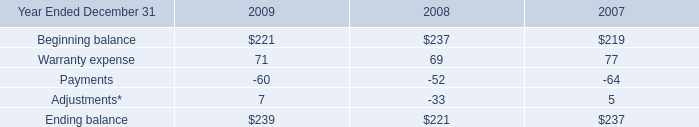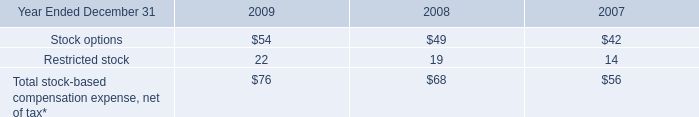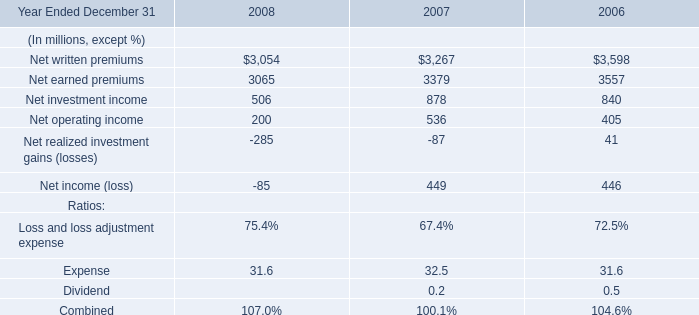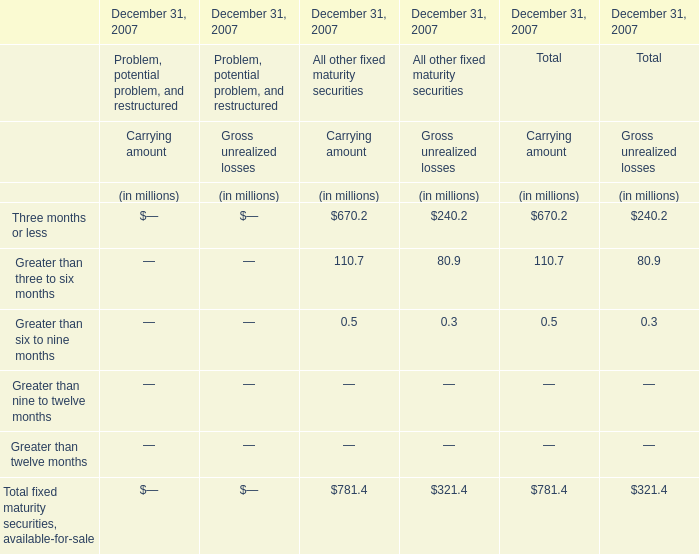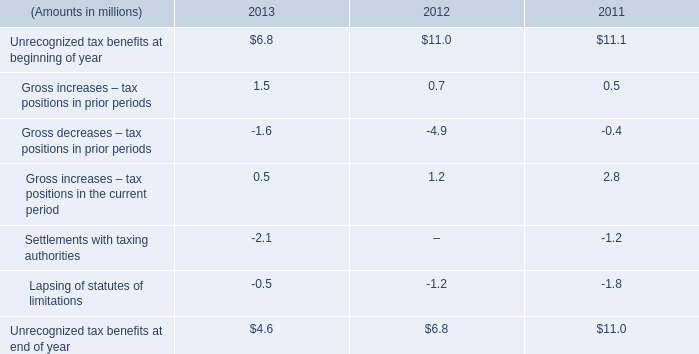what percent of unrecognized tax benefits as of 2012 would not impact the effective income tax rate if recognized? 
Computations: ((6.8 - 4.1) / 6.8)
Answer: 0.39706. 